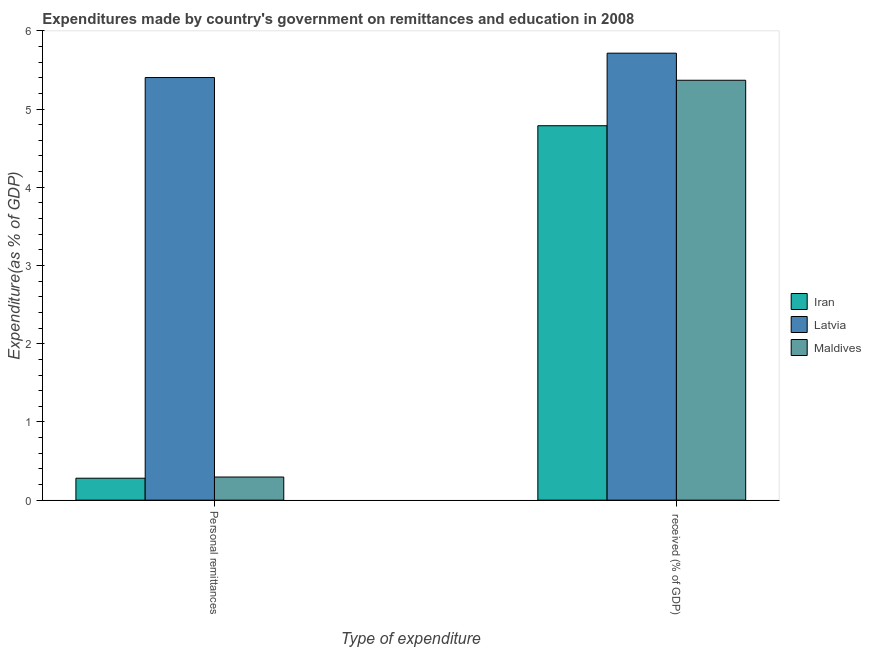How many different coloured bars are there?
Make the answer very short. 3. Are the number of bars per tick equal to the number of legend labels?
Make the answer very short. Yes. How many bars are there on the 2nd tick from the left?
Provide a short and direct response. 3. What is the label of the 2nd group of bars from the left?
Offer a very short reply.  received (% of GDP). What is the expenditure in personal remittances in Latvia?
Your answer should be very brief. 5.4. Across all countries, what is the maximum expenditure in personal remittances?
Your response must be concise. 5.4. Across all countries, what is the minimum expenditure in education?
Your answer should be very brief. 4.79. In which country was the expenditure in education maximum?
Offer a very short reply. Latvia. In which country was the expenditure in education minimum?
Keep it short and to the point. Iran. What is the total expenditure in personal remittances in the graph?
Ensure brevity in your answer.  5.98. What is the difference between the expenditure in education in Iran and that in Latvia?
Provide a succinct answer. -0.93. What is the difference between the expenditure in education in Latvia and the expenditure in personal remittances in Maldives?
Give a very brief answer. 5.42. What is the average expenditure in education per country?
Give a very brief answer. 5.29. What is the difference between the expenditure in personal remittances and expenditure in education in Latvia?
Your response must be concise. -0.31. What is the ratio of the expenditure in education in Iran to that in Latvia?
Make the answer very short. 0.84. What does the 2nd bar from the left in Personal remittances represents?
Make the answer very short. Latvia. What does the 1st bar from the right in Personal remittances represents?
Provide a succinct answer. Maldives. How many bars are there?
Provide a short and direct response. 6. Are all the bars in the graph horizontal?
Your answer should be very brief. No. What is the difference between two consecutive major ticks on the Y-axis?
Your answer should be compact. 1. Are the values on the major ticks of Y-axis written in scientific E-notation?
Ensure brevity in your answer.  No. Does the graph contain any zero values?
Keep it short and to the point. No. How many legend labels are there?
Offer a very short reply. 3. How are the legend labels stacked?
Your answer should be compact. Vertical. What is the title of the graph?
Your response must be concise. Expenditures made by country's government on remittances and education in 2008. What is the label or title of the X-axis?
Your response must be concise. Type of expenditure. What is the label or title of the Y-axis?
Your answer should be compact. Expenditure(as % of GDP). What is the Expenditure(as % of GDP) in Iran in Personal remittances?
Offer a very short reply. 0.28. What is the Expenditure(as % of GDP) of Latvia in Personal remittances?
Your answer should be very brief. 5.4. What is the Expenditure(as % of GDP) of Maldives in Personal remittances?
Provide a succinct answer. 0.3. What is the Expenditure(as % of GDP) in Iran in  received (% of GDP)?
Give a very brief answer. 4.79. What is the Expenditure(as % of GDP) of Latvia in  received (% of GDP)?
Ensure brevity in your answer.  5.71. What is the Expenditure(as % of GDP) of Maldives in  received (% of GDP)?
Your answer should be very brief. 5.37. Across all Type of expenditure, what is the maximum Expenditure(as % of GDP) of Iran?
Give a very brief answer. 4.79. Across all Type of expenditure, what is the maximum Expenditure(as % of GDP) in Latvia?
Give a very brief answer. 5.71. Across all Type of expenditure, what is the maximum Expenditure(as % of GDP) in Maldives?
Ensure brevity in your answer.  5.37. Across all Type of expenditure, what is the minimum Expenditure(as % of GDP) in Iran?
Provide a short and direct response. 0.28. Across all Type of expenditure, what is the minimum Expenditure(as % of GDP) in Latvia?
Offer a terse response. 5.4. Across all Type of expenditure, what is the minimum Expenditure(as % of GDP) in Maldives?
Offer a very short reply. 0.3. What is the total Expenditure(as % of GDP) in Iran in the graph?
Provide a succinct answer. 5.07. What is the total Expenditure(as % of GDP) of Latvia in the graph?
Ensure brevity in your answer.  11.12. What is the total Expenditure(as % of GDP) of Maldives in the graph?
Provide a succinct answer. 5.66. What is the difference between the Expenditure(as % of GDP) of Iran in Personal remittances and that in  received (% of GDP)?
Provide a succinct answer. -4.51. What is the difference between the Expenditure(as % of GDP) of Latvia in Personal remittances and that in  received (% of GDP)?
Offer a terse response. -0.31. What is the difference between the Expenditure(as % of GDP) of Maldives in Personal remittances and that in  received (% of GDP)?
Your answer should be compact. -5.07. What is the difference between the Expenditure(as % of GDP) of Iran in Personal remittances and the Expenditure(as % of GDP) of Latvia in  received (% of GDP)?
Your answer should be very brief. -5.43. What is the difference between the Expenditure(as % of GDP) in Iran in Personal remittances and the Expenditure(as % of GDP) in Maldives in  received (% of GDP)?
Make the answer very short. -5.09. What is the difference between the Expenditure(as % of GDP) of Latvia in Personal remittances and the Expenditure(as % of GDP) of Maldives in  received (% of GDP)?
Your response must be concise. 0.03. What is the average Expenditure(as % of GDP) of Iran per Type of expenditure?
Keep it short and to the point. 2.53. What is the average Expenditure(as % of GDP) of Latvia per Type of expenditure?
Provide a short and direct response. 5.56. What is the average Expenditure(as % of GDP) of Maldives per Type of expenditure?
Your answer should be very brief. 2.83. What is the difference between the Expenditure(as % of GDP) in Iran and Expenditure(as % of GDP) in Latvia in Personal remittances?
Your answer should be very brief. -5.12. What is the difference between the Expenditure(as % of GDP) of Iran and Expenditure(as % of GDP) of Maldives in Personal remittances?
Offer a very short reply. -0.02. What is the difference between the Expenditure(as % of GDP) in Latvia and Expenditure(as % of GDP) in Maldives in Personal remittances?
Offer a terse response. 5.11. What is the difference between the Expenditure(as % of GDP) of Iran and Expenditure(as % of GDP) of Latvia in  received (% of GDP)?
Ensure brevity in your answer.  -0.93. What is the difference between the Expenditure(as % of GDP) in Iran and Expenditure(as % of GDP) in Maldives in  received (% of GDP)?
Make the answer very short. -0.58. What is the difference between the Expenditure(as % of GDP) of Latvia and Expenditure(as % of GDP) of Maldives in  received (% of GDP)?
Ensure brevity in your answer.  0.35. What is the ratio of the Expenditure(as % of GDP) in Iran in Personal remittances to that in  received (% of GDP)?
Your answer should be very brief. 0.06. What is the ratio of the Expenditure(as % of GDP) in Latvia in Personal remittances to that in  received (% of GDP)?
Ensure brevity in your answer.  0.95. What is the ratio of the Expenditure(as % of GDP) in Maldives in Personal remittances to that in  received (% of GDP)?
Your response must be concise. 0.06. What is the difference between the highest and the second highest Expenditure(as % of GDP) of Iran?
Ensure brevity in your answer.  4.51. What is the difference between the highest and the second highest Expenditure(as % of GDP) of Latvia?
Provide a short and direct response. 0.31. What is the difference between the highest and the second highest Expenditure(as % of GDP) of Maldives?
Offer a very short reply. 5.07. What is the difference between the highest and the lowest Expenditure(as % of GDP) of Iran?
Your response must be concise. 4.51. What is the difference between the highest and the lowest Expenditure(as % of GDP) of Latvia?
Your answer should be very brief. 0.31. What is the difference between the highest and the lowest Expenditure(as % of GDP) in Maldives?
Your answer should be compact. 5.07. 